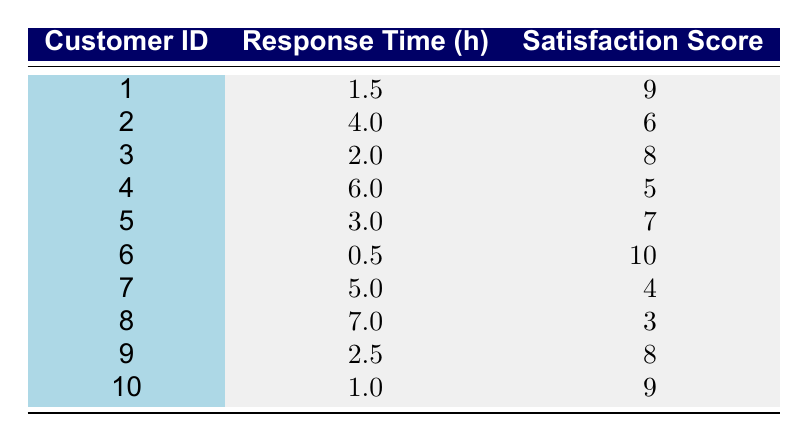What is the satisfaction score of the customer with the shortest service response time? The shortest service response time is 0.5 hours, which corresponds to Customer ID 6. Looking at the satisfaction score for this customer, it is 10.
Answer: 10 What is the total satisfaction score of all customers? To find the total satisfaction score, sum all the scores from the Satisfaction Score column: 9 + 6 + 8 + 5 + 7 + 10 + 4 + 3 + 8 + 9 = 69.
Answer: 69 Does Customer ID 8 have a satisfaction score greater than 5? The satisfaction score for Customer ID 8 is 3, which is not greater than 5, making this statement false.
Answer: No What is the average service response time across all customers? There are 10 customers. The sum of their service response times is 1.5 + 4 + 2 + 6 + 3 + 0.5 + 5 + 7 + 2.5 + 1 = 33. The average response time is 33 divided by 10, which equals 3.3 hours.
Answer: 3.3 Which customer had a satisfaction score of 4 and what was their service response time? Customer ID 7 has a satisfaction score of 4. The corresponding service response time for this customer is 5 hours.
Answer: Customer ID 7, 5 hours Is there a customer who received a satisfaction score of 10? Yes, Customer ID 6 received a satisfaction score of 10.
Answer: Yes What is the difference in satisfaction scores between the customer with the highest and the lowest score? The highest satisfaction score is 10 (Customer ID 6) and the lowest is 3 (Customer ID 8). The difference is 10 - 3 = 7.
Answer: 7 How many customers had a satisfaction score of 8 or higher? The customers with satisfaction scores of 8 or higher are Customer IDs 1, 3, 6, 9, and 10. That totals to 5 customers.
Answer: 5 If we ignore the top customer with a satisfaction score of 10, what would the average score be for the remaining customers? Ignoring the top score of 10, we sum the remaining satisfaction scores (9 + 6 + 8 + 5 + 7 + 4 + 3 + 8 + 9 = 59) and divide by 9 remaining customers. The average is thus 59 divided by 9, which is approximately 6.56.
Answer: 6.56 